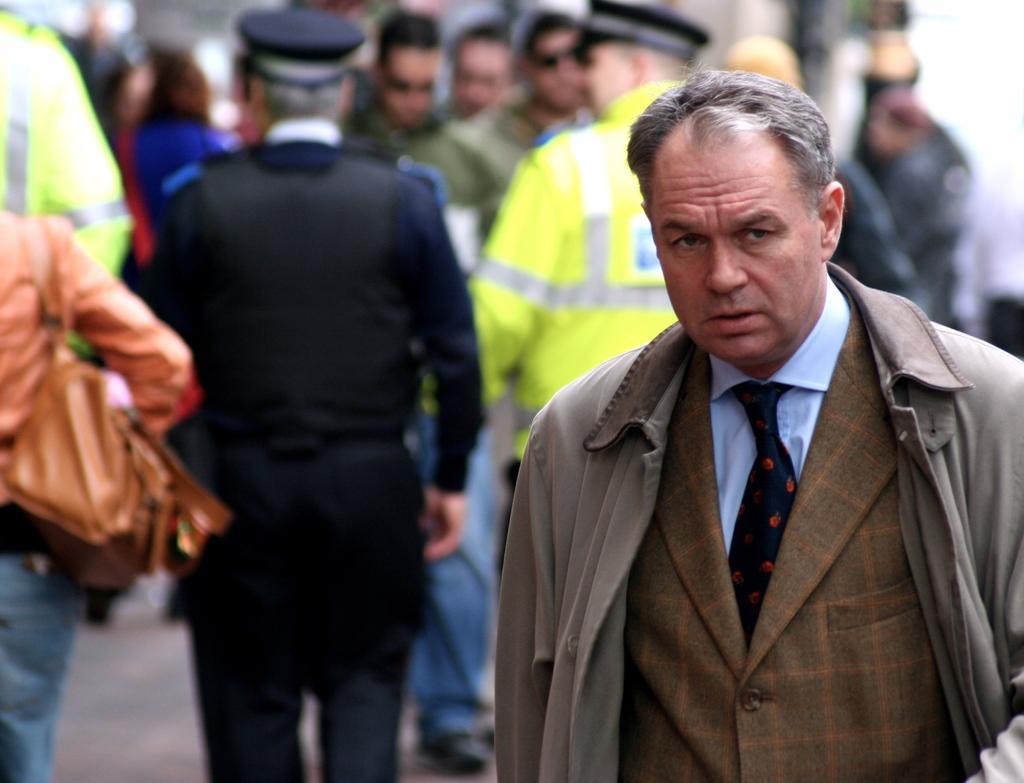Describe this image in one or two sentences. In this image, I can see a man standing. In the background, there are group of people standing. 